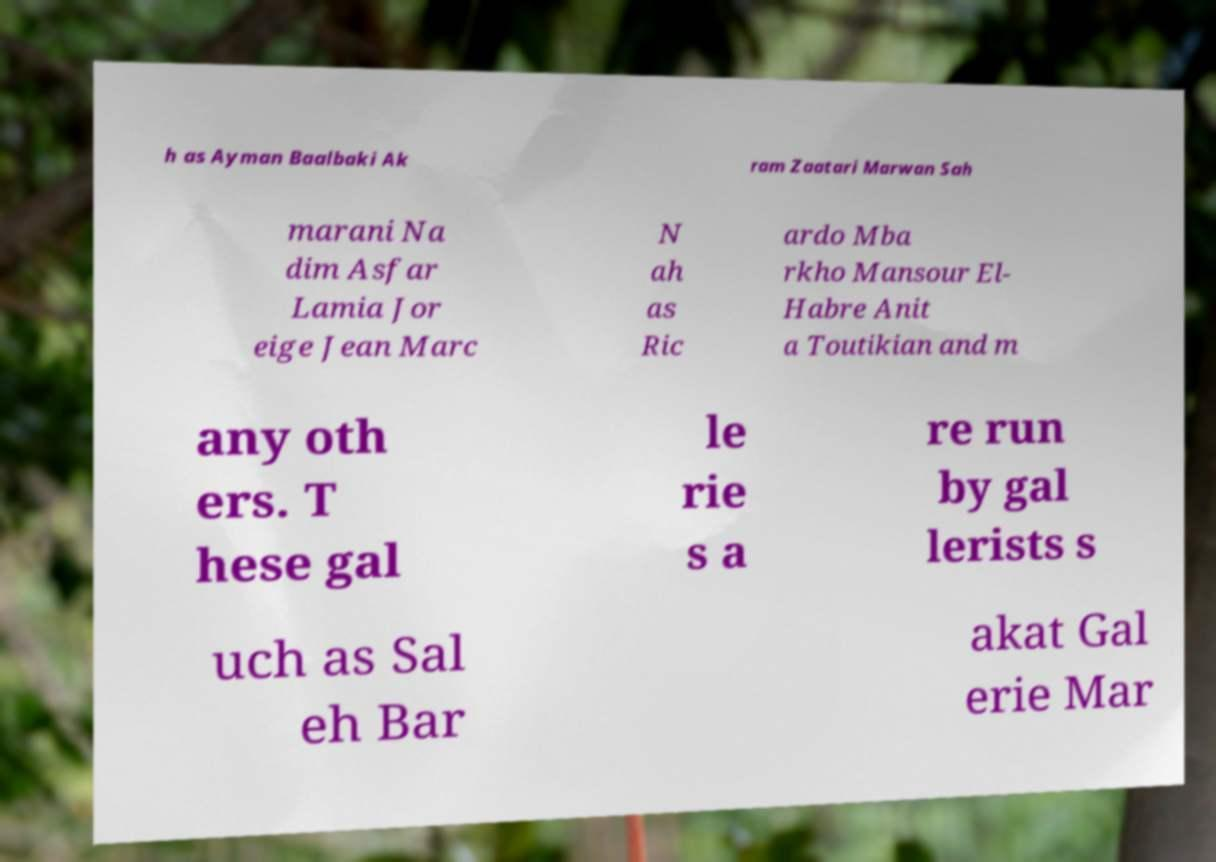Could you assist in decoding the text presented in this image and type it out clearly? h as Ayman Baalbaki Ak ram Zaatari Marwan Sah marani Na dim Asfar Lamia Jor eige Jean Marc N ah as Ric ardo Mba rkho Mansour El- Habre Anit a Toutikian and m any oth ers. T hese gal le rie s a re run by gal lerists s uch as Sal eh Bar akat Gal erie Mar 